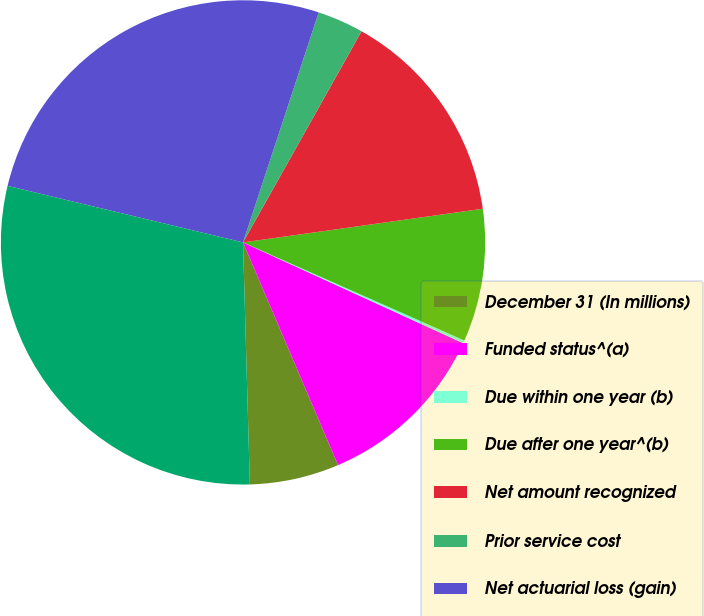Convert chart to OTSL. <chart><loc_0><loc_0><loc_500><loc_500><pie_chart><fcel>December 31 (In millions)<fcel>Funded status^(a)<fcel>Due within one year (b)<fcel>Due after one year^(b)<fcel>Net amount recognized<fcel>Prior service cost<fcel>Net actuarial loss (gain)<fcel>Total<nl><fcel>5.97%<fcel>11.75%<fcel>0.19%<fcel>8.86%<fcel>14.64%<fcel>3.08%<fcel>26.31%<fcel>29.2%<nl></chart> 